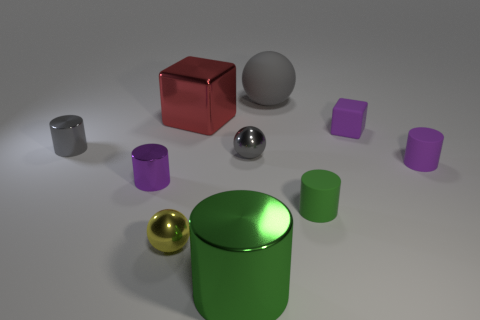There is a green object that is to the right of the large gray ball; what size is it?
Keep it short and to the point. Small. What is the shape of the tiny matte thing that is the same color as the big metallic cylinder?
Give a very brief answer. Cylinder. Are the small gray cylinder and the purple cylinder left of the large sphere made of the same material?
Provide a short and direct response. Yes. There is a tiny purple object that is in front of the purple cylinder that is right of the yellow thing; how many tiny cylinders are in front of it?
Provide a short and direct response. 1. How many purple things are small rubber objects or small rubber cylinders?
Make the answer very short. 2. There is a green object that is to the left of the big gray sphere; what shape is it?
Offer a very short reply. Cylinder. There is a rubber cube that is the same size as the purple metallic object; what is its color?
Give a very brief answer. Purple. Is the shape of the large red shiny thing the same as the small purple thing on the left side of the green matte thing?
Provide a short and direct response. No. There is a cylinder to the right of the small matte cylinder in front of the purple rubber object right of the purple matte cube; what is its material?
Provide a short and direct response. Rubber. How many big objects are either green matte cylinders or yellow shiny cubes?
Make the answer very short. 0. 